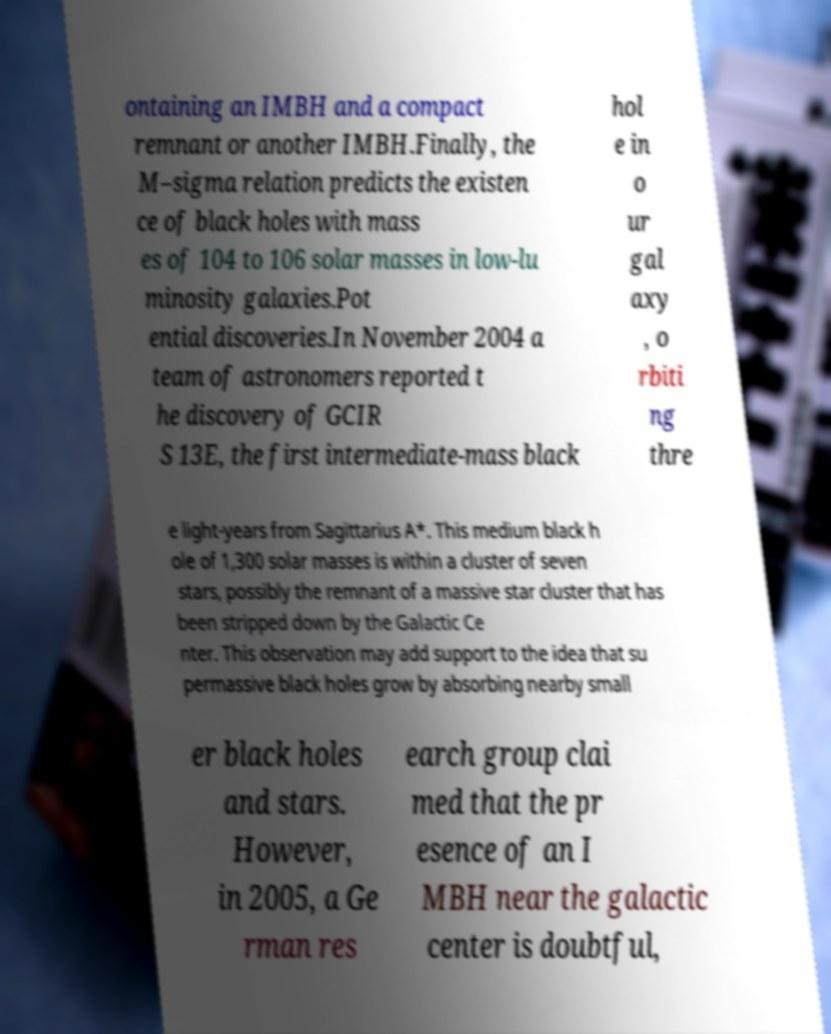For documentation purposes, I need the text within this image transcribed. Could you provide that? ontaining an IMBH and a compact remnant or another IMBH.Finally, the M–sigma relation predicts the existen ce of black holes with mass es of 104 to 106 solar masses in low-lu minosity galaxies.Pot ential discoveries.In November 2004 a team of astronomers reported t he discovery of GCIR S 13E, the first intermediate-mass black hol e in o ur gal axy , o rbiti ng thre e light-years from Sagittarius A*. This medium black h ole of 1,300 solar masses is within a cluster of seven stars, possibly the remnant of a massive star cluster that has been stripped down by the Galactic Ce nter. This observation may add support to the idea that su permassive black holes grow by absorbing nearby small er black holes and stars. However, in 2005, a Ge rman res earch group clai med that the pr esence of an I MBH near the galactic center is doubtful, 